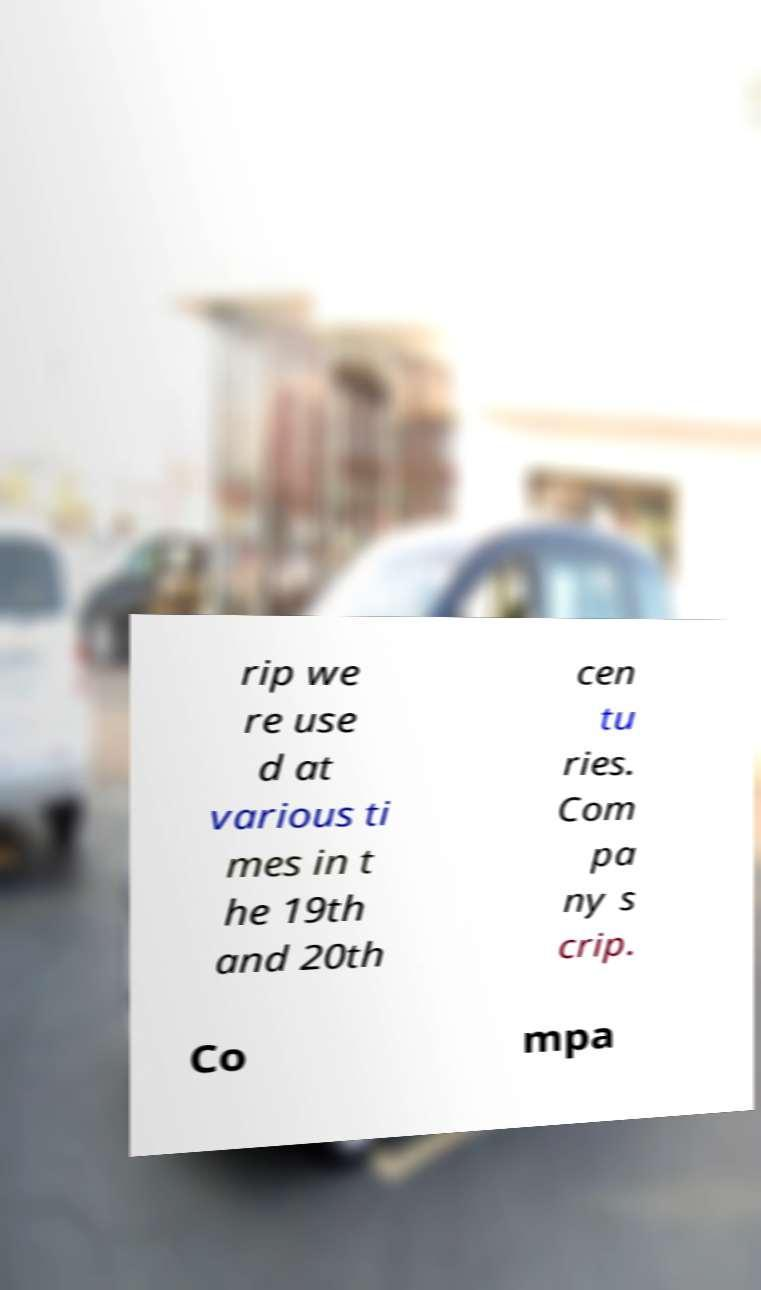I need the written content from this picture converted into text. Can you do that? rip we re use d at various ti mes in t he 19th and 20th cen tu ries. Com pa ny s crip. Co mpa 